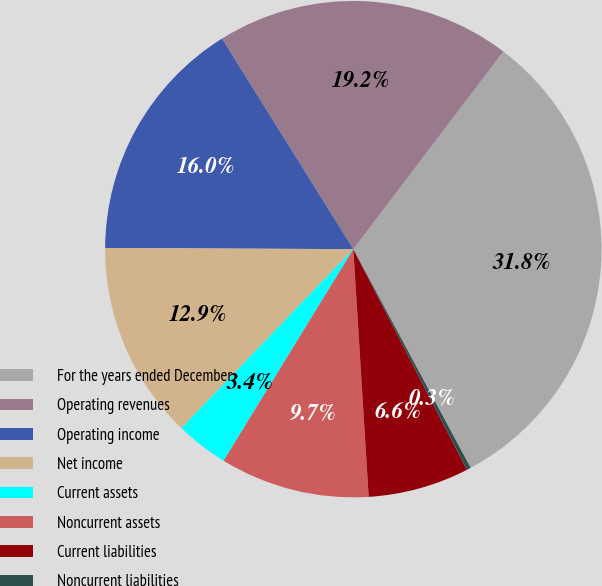<chart> <loc_0><loc_0><loc_500><loc_500><pie_chart><fcel>For the years ended December<fcel>Operating revenues<fcel>Operating income<fcel>Net income<fcel>Current assets<fcel>Noncurrent assets<fcel>Current liabilities<fcel>Noncurrent liabilities<nl><fcel>31.83%<fcel>19.21%<fcel>16.05%<fcel>12.89%<fcel>3.43%<fcel>9.74%<fcel>6.58%<fcel>0.27%<nl></chart> 